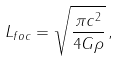<formula> <loc_0><loc_0><loc_500><loc_500>L _ { f o c } = \sqrt { \frac { \pi c ^ { 2 } } { 4 G \rho } } \, ,</formula> 